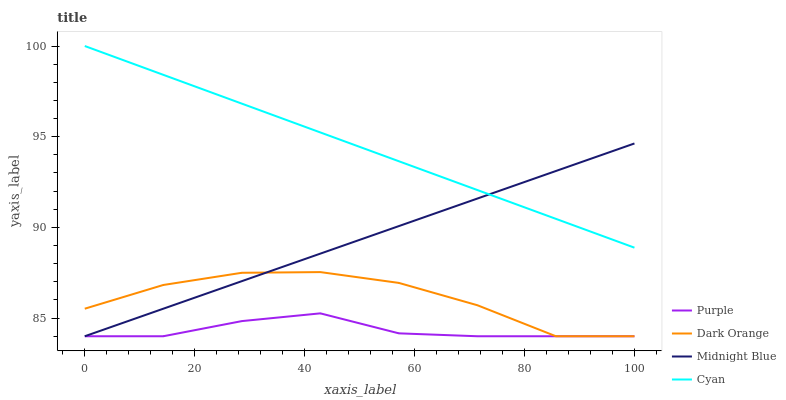Does Dark Orange have the minimum area under the curve?
Answer yes or no. No. Does Dark Orange have the maximum area under the curve?
Answer yes or no. No. Is Dark Orange the smoothest?
Answer yes or no. No. Is Midnight Blue the roughest?
Answer yes or no. No. Does Cyan have the lowest value?
Answer yes or no. No. Does Dark Orange have the highest value?
Answer yes or no. No. Is Purple less than Cyan?
Answer yes or no. Yes. Is Cyan greater than Dark Orange?
Answer yes or no. Yes. Does Purple intersect Cyan?
Answer yes or no. No. 